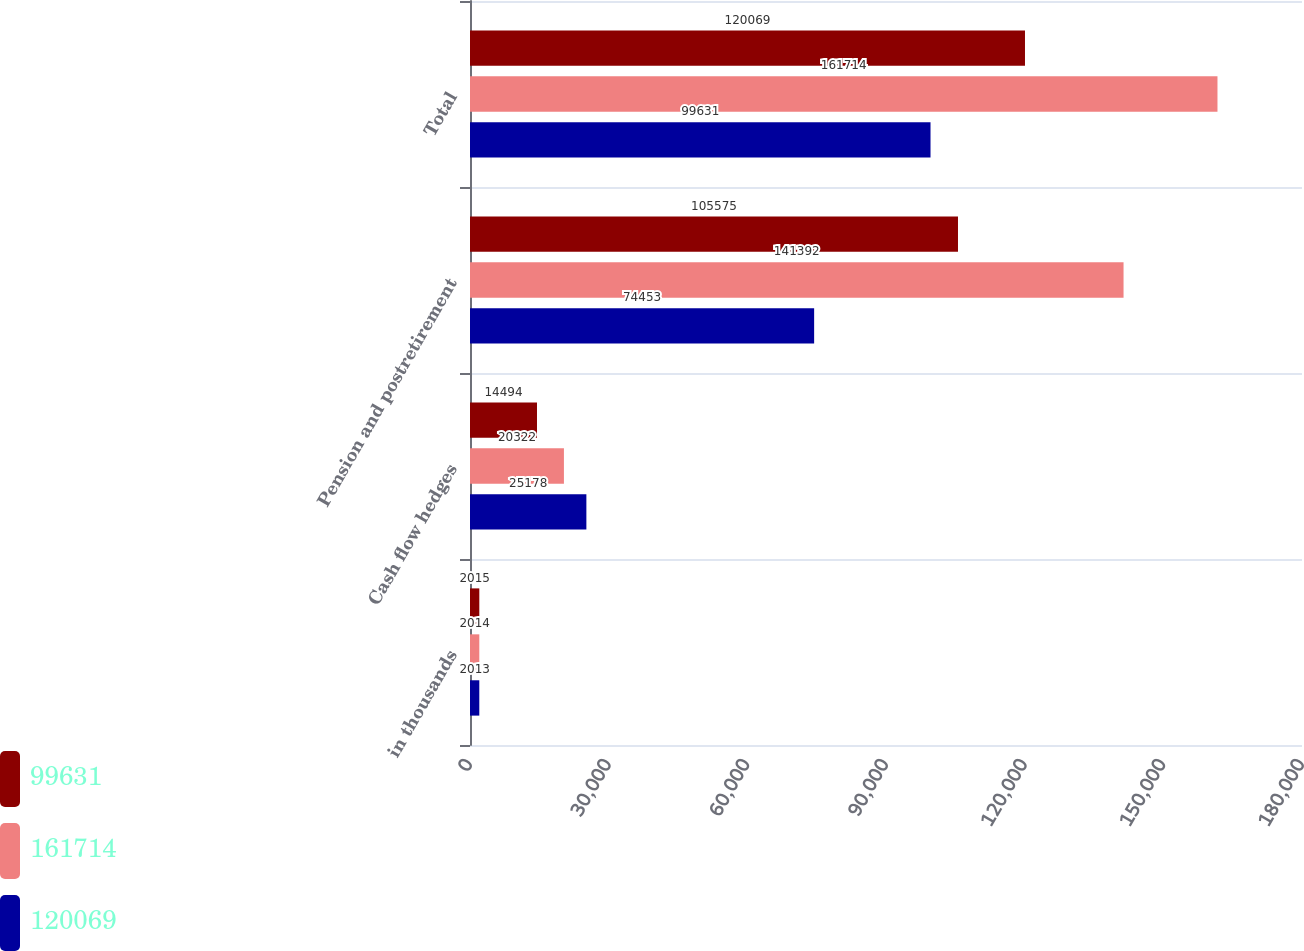<chart> <loc_0><loc_0><loc_500><loc_500><stacked_bar_chart><ecel><fcel>in thousands<fcel>Cash flow hedges<fcel>Pension and postretirement<fcel>Total<nl><fcel>99631<fcel>2015<fcel>14494<fcel>105575<fcel>120069<nl><fcel>161714<fcel>2014<fcel>20322<fcel>141392<fcel>161714<nl><fcel>120069<fcel>2013<fcel>25178<fcel>74453<fcel>99631<nl></chart> 